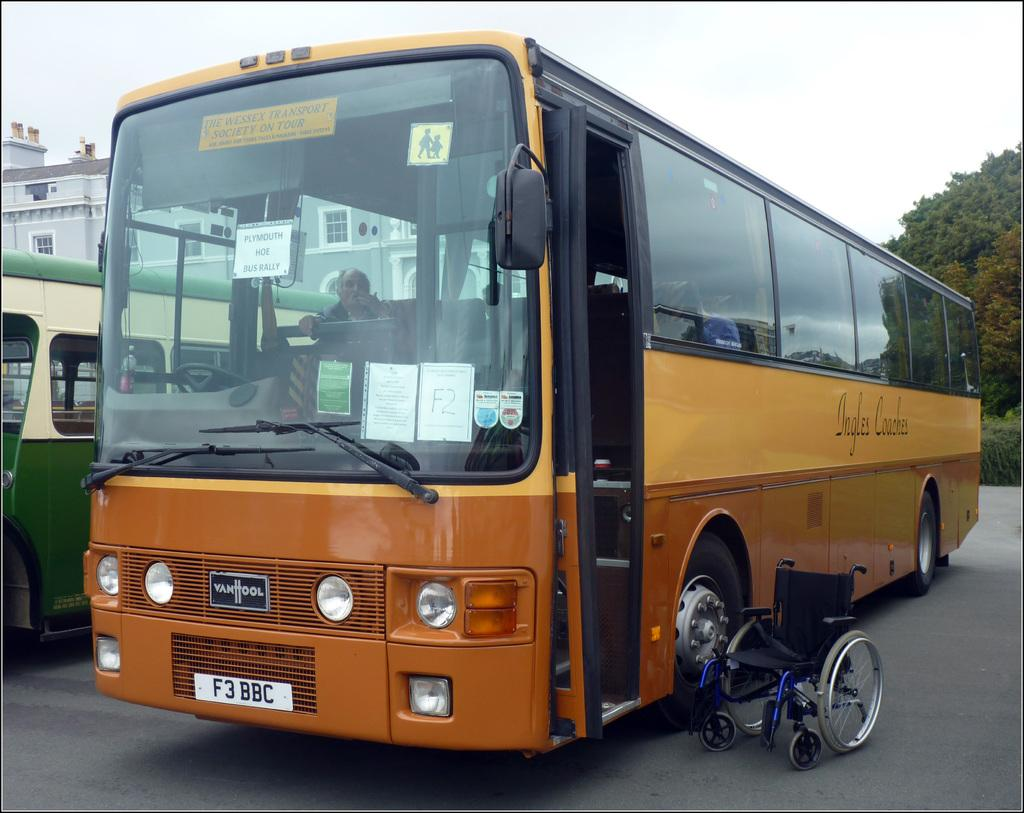Provide a one-sentence caption for the provided image. a bus with the letters 'f3bbc' on the front license plates. 